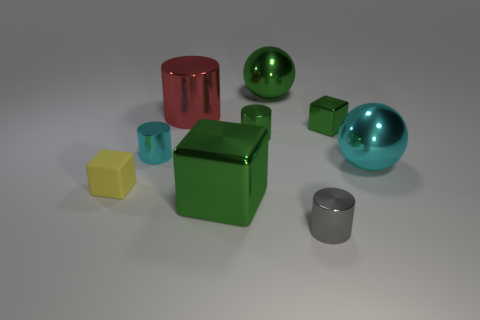Subtract 1 cylinders. How many cylinders are left? 3 Subtract all balls. How many objects are left? 7 Add 1 green metallic cylinders. How many green metallic cylinders exist? 2 Subtract 1 gray cylinders. How many objects are left? 8 Subtract all gray cylinders. Subtract all small green metallic cylinders. How many objects are left? 7 Add 8 small cyan objects. How many small cyan objects are left? 9 